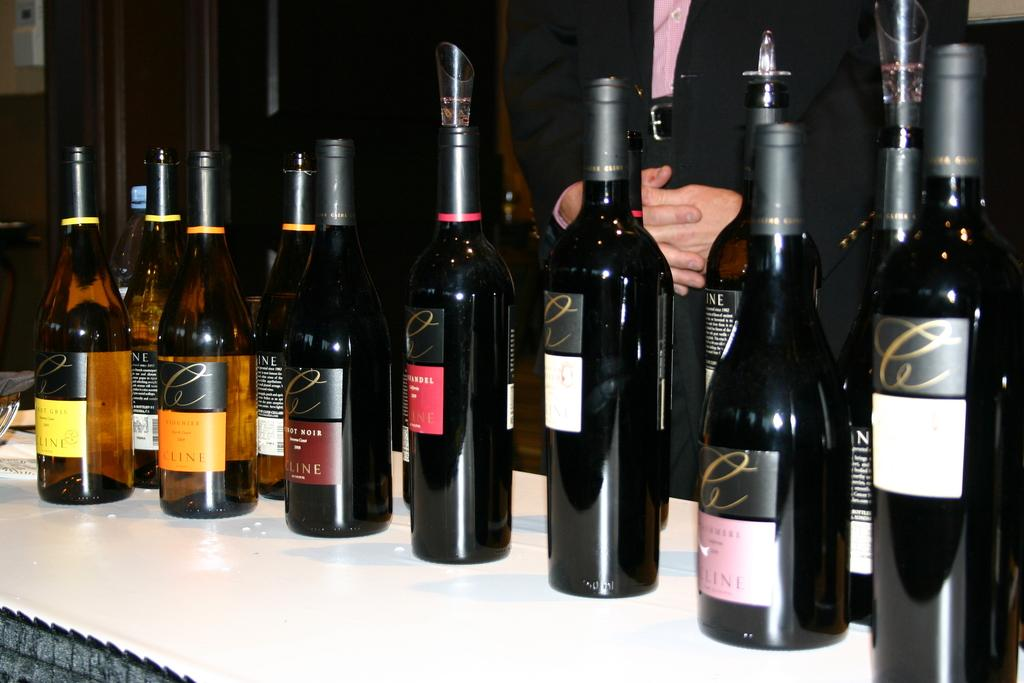What objects can be seen in the image? There are bottles in the image. Can you describe the person in the image? There is a person behind the bottles in the image. What type of knot is being tied by the person in the image? There is no knot or tying activity present in the image; the person is simply behind the bottles. 